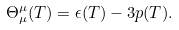Convert formula to latex. <formula><loc_0><loc_0><loc_500><loc_500>\Theta _ { \mu } ^ { \mu } ( T ) = \epsilon ( T ) - 3 p ( T ) .</formula> 